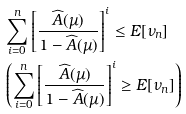<formula> <loc_0><loc_0><loc_500><loc_500>& \sum _ { i = 0 } ^ { n } \left [ \frac { \widehat { A } ( \mu ) } { 1 - \widehat { A } ( \mu ) } \right ] ^ { i } \leq E [ \nu _ { n } ] \\ & \left ( \sum _ { i = 0 } ^ { n } \left [ \frac { \widehat { A } ( \mu ) } { 1 - \widehat { A } ( \mu ) } \right ] ^ { i } \geq E [ \nu _ { n } ] \right )</formula> 